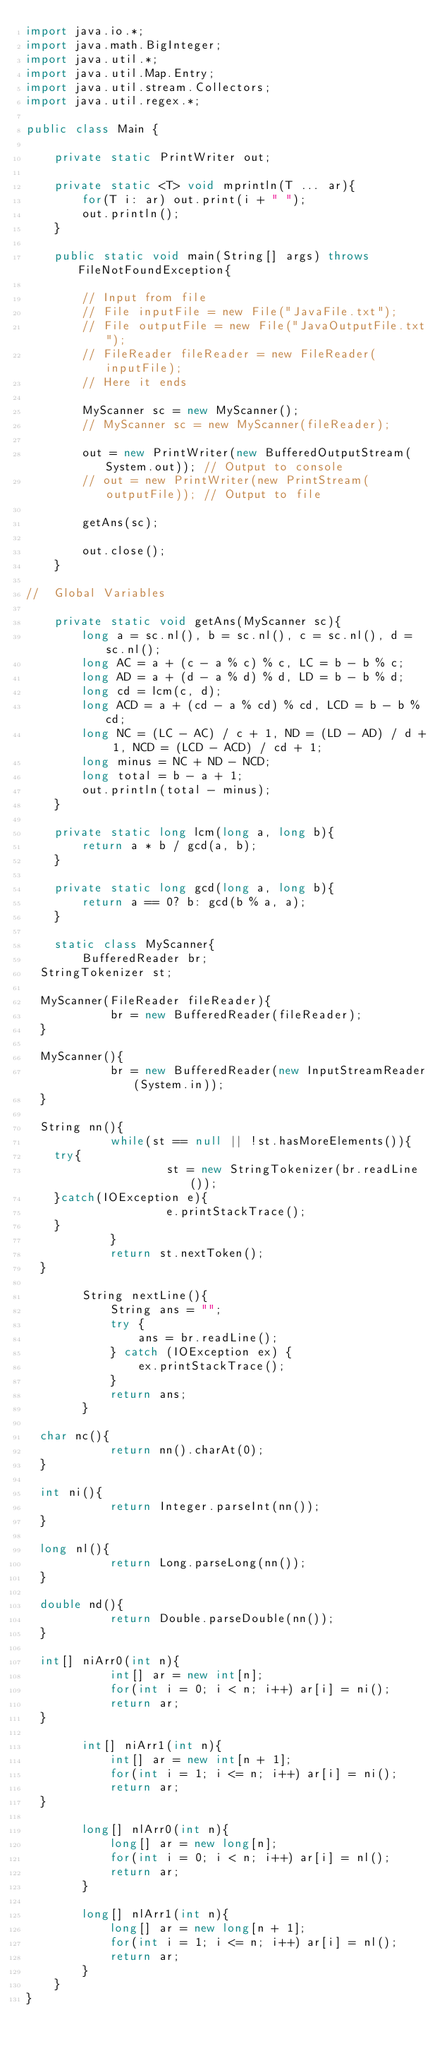<code> <loc_0><loc_0><loc_500><loc_500><_Java_>import java.io.*;
import java.math.BigInteger;
import java.util.*;
import java.util.Map.Entry;
import java.util.stream.Collectors;
import java.util.regex.*;

public class Main {
    
    private static PrintWriter out;
    
    private static <T> void mprintln(T ... ar){
        for(T i: ar) out.print(i + " ");
        out.println();
    }
    
    public static void main(String[] args) throws FileNotFoundException{

        // Input from file
        // File inputFile = new File("JavaFile.txt");
        // File outputFile = new File("JavaOutputFile.txt");
        // FileReader fileReader = new FileReader(inputFile);
        // Here it ends

        MyScanner sc = new MyScanner();
        // MyScanner sc = new MyScanner(fileReader);

        out = new PrintWriter(new BufferedOutputStream(System.out)); // Output to console
        // out = new PrintWriter(new PrintStream(outputFile)); // Output to file

        getAns(sc);

        out.close(); 
    }
    
//  Global Variables  
    
    private static void getAns(MyScanner sc){
        long a = sc.nl(), b = sc.nl(), c = sc.nl(), d = sc.nl();
        long AC = a + (c - a % c) % c, LC = b - b % c;
        long AD = a + (d - a % d) % d, LD = b - b % d;
        long cd = lcm(c, d);
        long ACD = a + (cd - a % cd) % cd, LCD = b - b % cd;
        long NC = (LC - AC) / c + 1, ND = (LD - AD) / d + 1, NCD = (LCD - ACD) / cd + 1;
        long minus = NC + ND - NCD;
        long total = b - a + 1;
        out.println(total - minus);
    }
    
    private static long lcm(long a, long b){
        return a * b / gcd(a, b);
    }
    
    private static long gcd(long a, long b){
        return a == 0? b: gcd(b % a, a);
    }
    
    static class MyScanner{
        BufferedReader br;
	StringTokenizer st;

	MyScanner(FileReader fileReader){
            br = new BufferedReader(fileReader);
	}

	MyScanner(){
            br = new BufferedReader(new InputStreamReader(System.in));
	}

	String nn(){
            while(st == null || !st.hasMoreElements()){
		try{
                    st = new StringTokenizer(br.readLine());
		}catch(IOException e){
                    e.printStackTrace();
		}
            }
            return st.nextToken();
	}
        
        String nextLine(){
            String ans = "";
            try {
                ans = br.readLine();
            } catch (IOException ex) {
                ex.printStackTrace();
            }
            return ans;
        }

	char nc(){
            return nn().charAt(0);
	}

	int ni(){
            return Integer.parseInt(nn());
	}

	long nl(){
            return Long.parseLong(nn());
	}

	double nd(){
            return Double.parseDouble(nn());
	}

	int[] niArr0(int n){
            int[] ar = new int[n];
            for(int i = 0; i < n; i++) ar[i] = ni();
            return ar;
	}

        int[] niArr1(int n){
            int[] ar = new int[n + 1];
            for(int i = 1; i <= n; i++) ar[i] = ni();
            return ar;
	}

        long[] nlArr0(int n){
            long[] ar = new long[n];
            for(int i = 0; i < n; i++) ar[i] = nl();
            return ar;
        }

        long[] nlArr1(int n){
            long[] ar = new long[n + 1];
            for(int i = 1; i <= n; i++) ar[i] = nl();
            return ar;
        }
    }
}</code> 